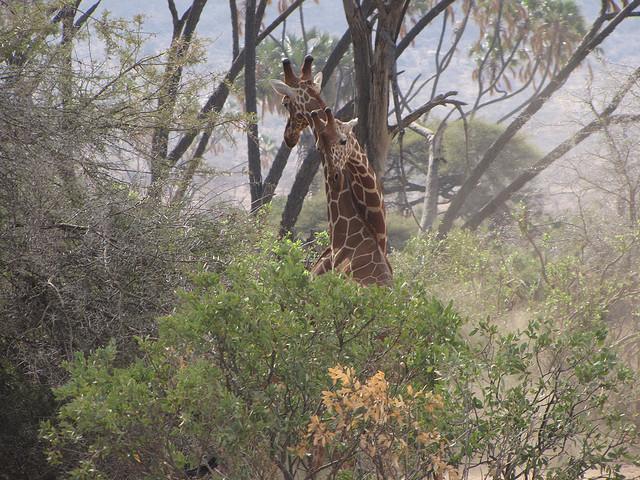Are the giraffes touching each other?
Give a very brief answer. Yes. What is this animal?
Concise answer only. Giraffe. Is this a grizzly bear?
Answer briefly. No. Are there birds on the tree?
Short answer required. No. How many giraffes are leaning towards the trees?
Give a very brief answer. 2. What color are the leaves?
Concise answer only. Green. Is it a clear day?
Be succinct. No. What are the giraffes surrounded by?
Answer briefly. Trees. What season is it in this picture?
Write a very short answer. Spring. 